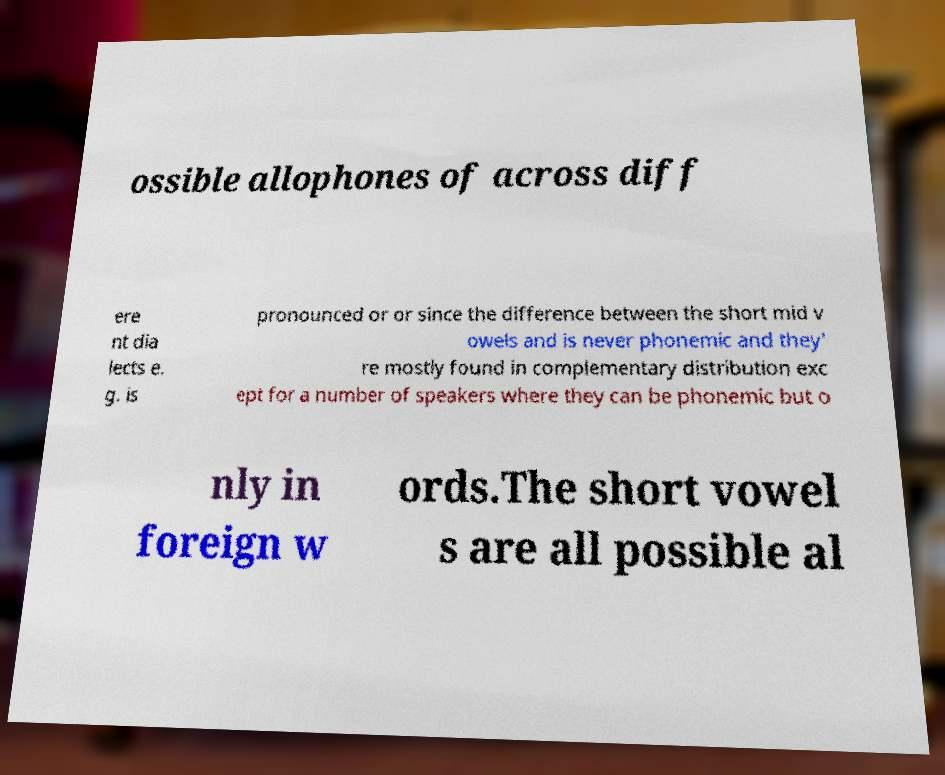There's text embedded in this image that I need extracted. Can you transcribe it verbatim? ossible allophones of across diff ere nt dia lects e. g. is pronounced or or since the difference between the short mid v owels and is never phonemic and they' re mostly found in complementary distribution exc ept for a number of speakers where they can be phonemic but o nly in foreign w ords.The short vowel s are all possible al 